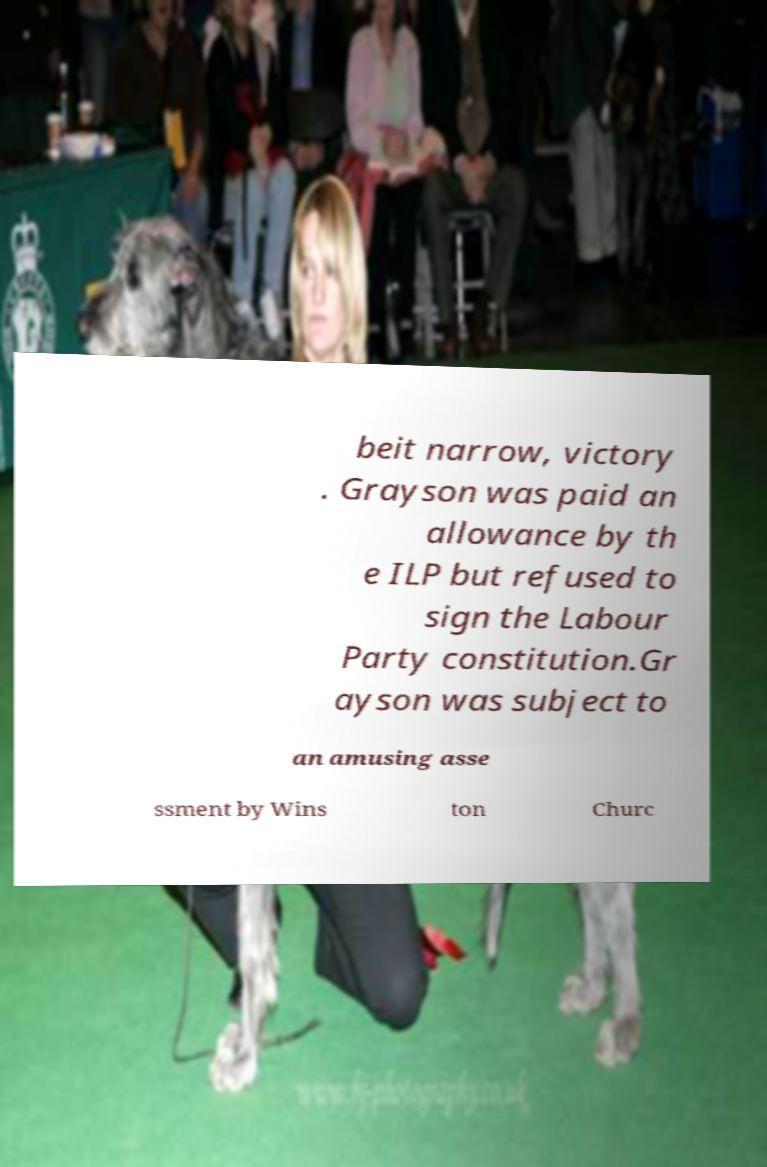There's text embedded in this image that I need extracted. Can you transcribe it verbatim? beit narrow, victory . Grayson was paid an allowance by th e ILP but refused to sign the Labour Party constitution.Gr ayson was subject to an amusing asse ssment by Wins ton Churc 